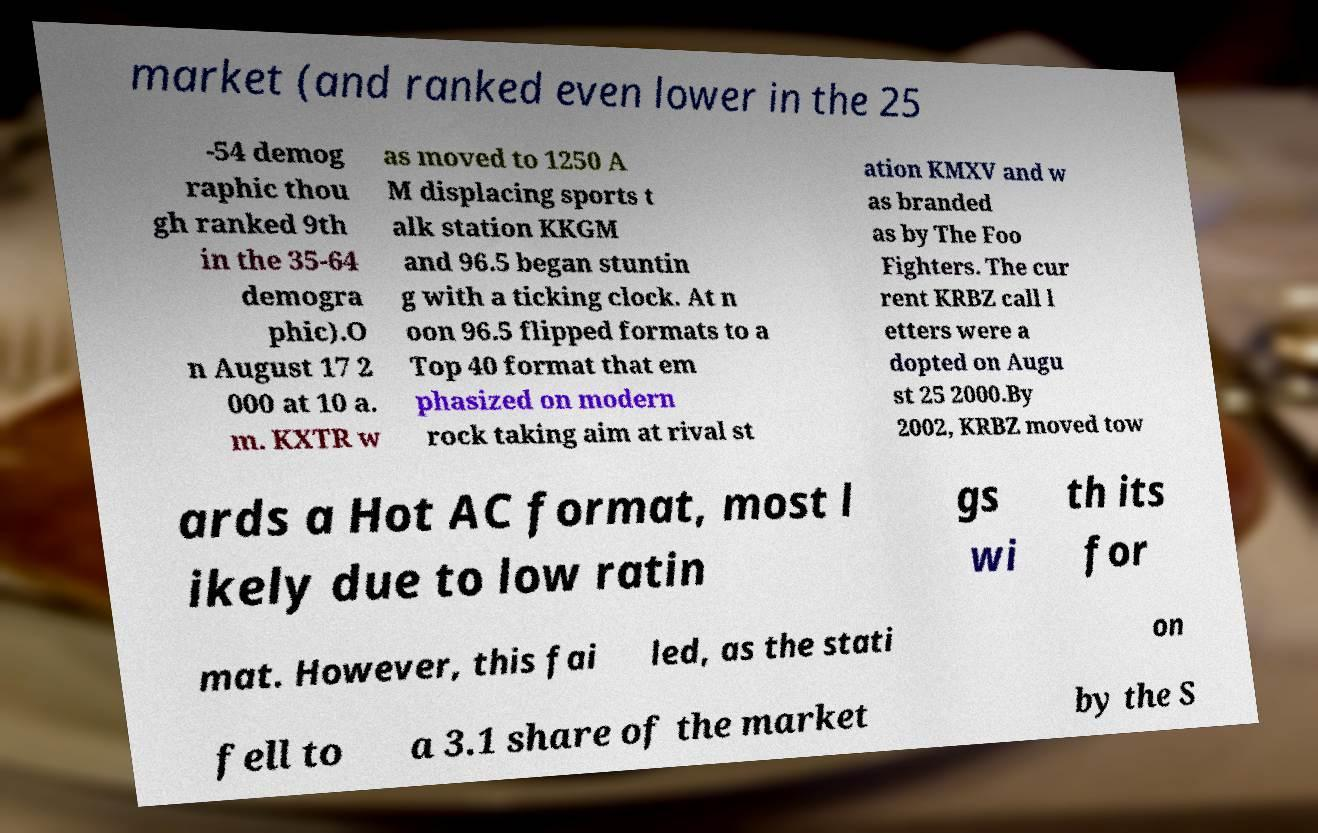Please identify and transcribe the text found in this image. market (and ranked even lower in the 25 -54 demog raphic thou gh ranked 9th in the 35-64 demogra phic).O n August 17 2 000 at 10 a. m. KXTR w as moved to 1250 A M displacing sports t alk station KKGM and 96.5 began stuntin g with a ticking clock. At n oon 96.5 flipped formats to a Top 40 format that em phasized on modern rock taking aim at rival st ation KMXV and w as branded as by The Foo Fighters. The cur rent KRBZ call l etters were a dopted on Augu st 25 2000.By 2002, KRBZ moved tow ards a Hot AC format, most l ikely due to low ratin gs wi th its for mat. However, this fai led, as the stati on fell to a 3.1 share of the market by the S 